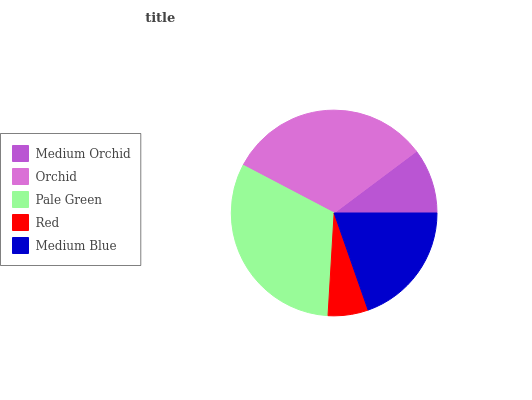Is Red the minimum?
Answer yes or no. Yes. Is Orchid the maximum?
Answer yes or no. Yes. Is Pale Green the minimum?
Answer yes or no. No. Is Pale Green the maximum?
Answer yes or no. No. Is Orchid greater than Pale Green?
Answer yes or no. Yes. Is Pale Green less than Orchid?
Answer yes or no. Yes. Is Pale Green greater than Orchid?
Answer yes or no. No. Is Orchid less than Pale Green?
Answer yes or no. No. Is Medium Blue the high median?
Answer yes or no. Yes. Is Medium Blue the low median?
Answer yes or no. Yes. Is Orchid the high median?
Answer yes or no. No. Is Red the low median?
Answer yes or no. No. 